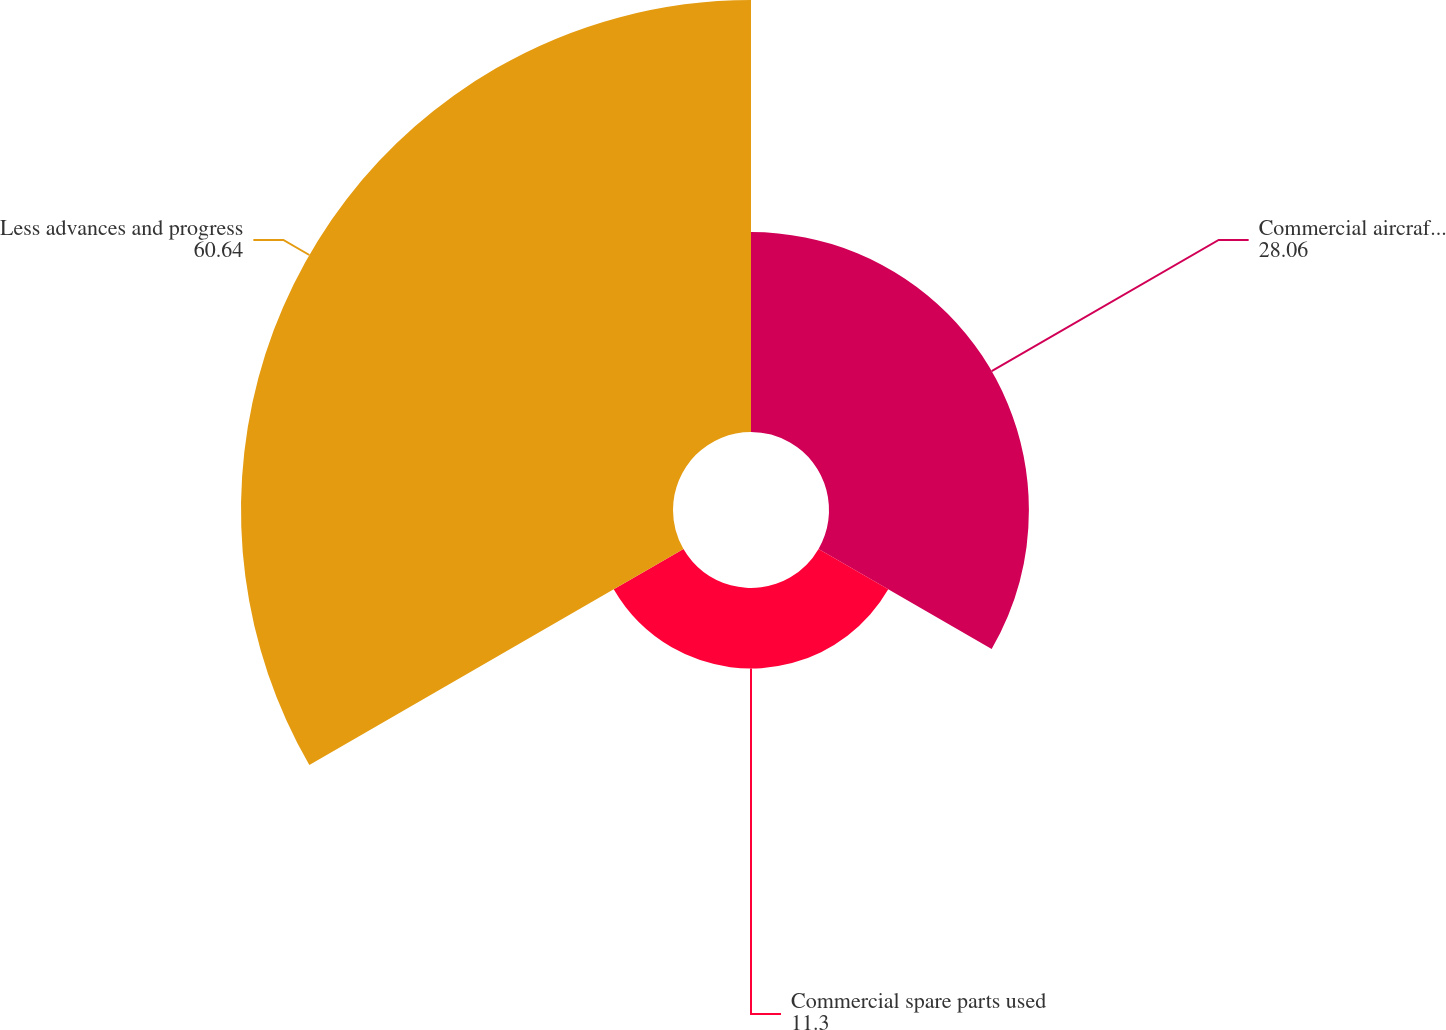Convert chart to OTSL. <chart><loc_0><loc_0><loc_500><loc_500><pie_chart><fcel>Commercial aircraft programs<fcel>Commercial spare parts used<fcel>Less advances and progress<nl><fcel>28.06%<fcel>11.3%<fcel>60.64%<nl></chart> 